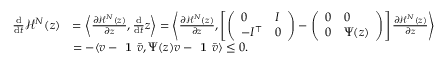Convert formula to latex. <formula><loc_0><loc_0><loc_500><loc_500>\begin{array} { r l } { \frac { \mathrm d } { \mathrm d t } \mathcal { H } ^ { N } ( z ) } & { = \left \langle \frac { \partial \mathcal { H } ^ { N } ( z ) } { \partial z } , \frac { \mathrm d } { \mathrm d t } z \right \rangle = \left \langle \frac { \partial \mathcal { H } ^ { N } ( z ) } { \partial z } , \left [ \left ( \begin{array} { l l } { 0 } & { I } \\ { - I ^ { \top } } & { 0 } \end{array} \right ) - \left ( \begin{array} { l l } { 0 } & { 0 } \\ { 0 } & { \Psi ( z ) } \end{array} \right ) \right ] \frac { \partial \mathcal { H } ^ { N } ( z ) } { \partial z } \right \rangle } \\ & { = - \langle v - 1 \bar { v } , \Psi ( z ) v - 1 \bar { v } \rangle \leq 0 . } \end{array}</formula> 